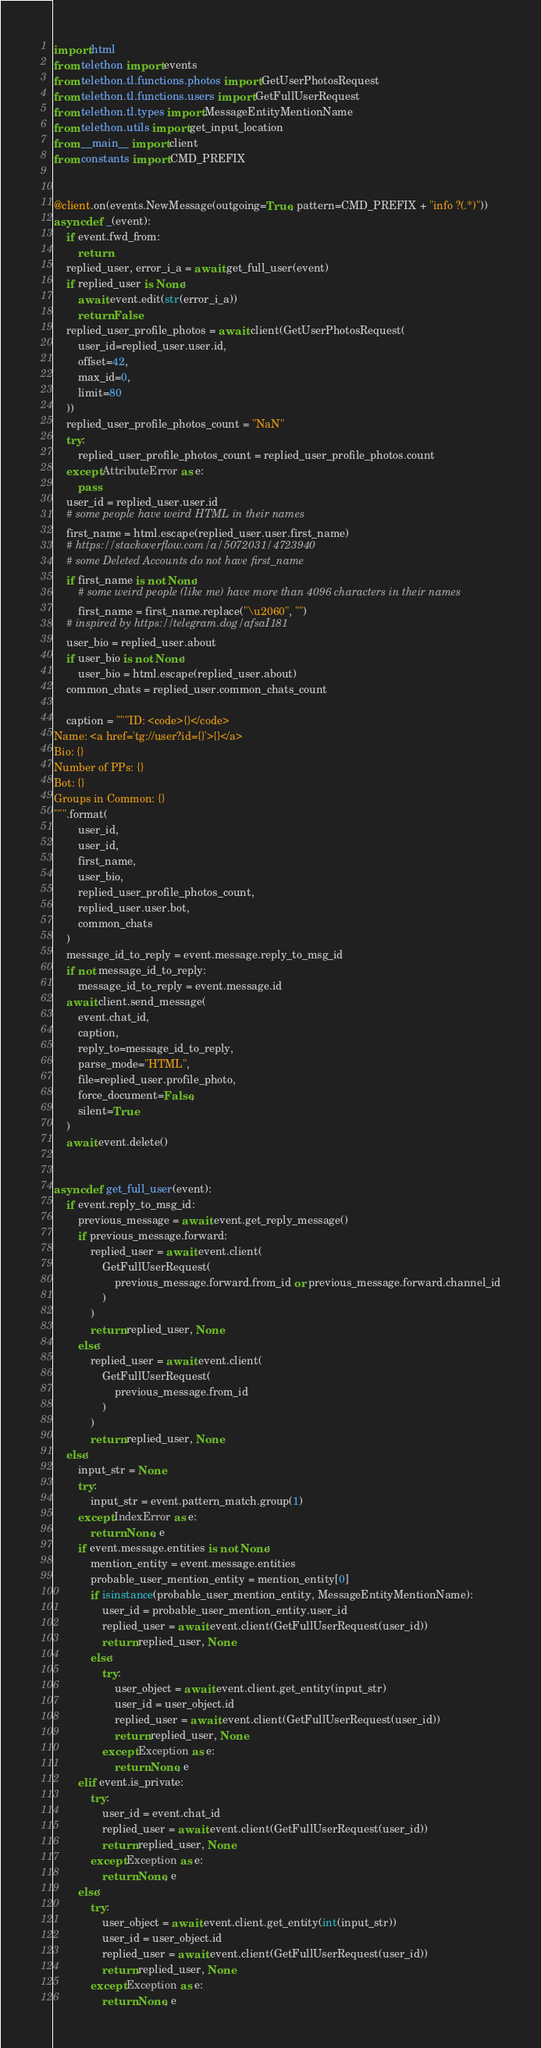Convert code to text. <code><loc_0><loc_0><loc_500><loc_500><_Python_>import html
from telethon import events
from telethon.tl.functions.photos import GetUserPhotosRequest
from telethon.tl.functions.users import GetFullUserRequest
from telethon.tl.types import MessageEntityMentionName
from telethon.utils import get_input_location
from __main__ import client
from constants import CMD_PREFIX


@client.on(events.NewMessage(outgoing=True, pattern=CMD_PREFIX + "info ?(.*)"))
async def _(event):
    if event.fwd_from:
        return
    replied_user, error_i_a = await get_full_user(event)
    if replied_user is None:
        await event.edit(str(error_i_a))
        return False
    replied_user_profile_photos = await client(GetUserPhotosRequest(
        user_id=replied_user.user.id,
        offset=42,
        max_id=0,
        limit=80
    ))
    replied_user_profile_photos_count = "NaN"
    try:
        replied_user_profile_photos_count = replied_user_profile_photos.count
    except AttributeError as e:
        pass
    user_id = replied_user.user.id
    # some people have weird HTML in their names
    first_name = html.escape(replied_user.user.first_name)
    # https://stackoverflow.com/a/5072031/4723940
    # some Deleted Accounts do not have first_name
    if first_name is not None:
        # some weird people (like me) have more than 4096 characters in their names
        first_name = first_name.replace("\u2060", "")
    # inspired by https://telegram.dog/afsaI181
    user_bio = replied_user.about
    if user_bio is not None:
        user_bio = html.escape(replied_user.about)
    common_chats = replied_user.common_chats_count
    
    caption = """ID: <code>{}</code>
Name: <a href='tg://user?id={}'>{}</a>
Bio: {}
Number of PPs: {}
Bot: {}
Groups in Common: {}
""".format(
        user_id,
        user_id,
        first_name,
        user_bio,
        replied_user_profile_photos_count,
        replied_user.user.bot,
        common_chats
    )
    message_id_to_reply = event.message.reply_to_msg_id
    if not message_id_to_reply:
        message_id_to_reply = event.message.id
    await client.send_message(
        event.chat_id,
        caption,
        reply_to=message_id_to_reply,
        parse_mode="HTML",
        file=replied_user.profile_photo,
        force_document=False,
        silent=True
    )
    await event.delete()


async def get_full_user(event):
    if event.reply_to_msg_id:
        previous_message = await event.get_reply_message()
        if previous_message.forward:
            replied_user = await event.client(
                GetFullUserRequest(
                    previous_message.forward.from_id or previous_message.forward.channel_id
                )
            )
            return replied_user, None
        else:
            replied_user = await event.client(
                GetFullUserRequest(
                    previous_message.from_id
                )
            )
            return replied_user, None
    else:
        input_str = None
        try:
            input_str = event.pattern_match.group(1)
        except IndexError as e:
            return None, e
        if event.message.entities is not None:
            mention_entity = event.message.entities
            probable_user_mention_entity = mention_entity[0]
            if isinstance(probable_user_mention_entity, MessageEntityMentionName):
                user_id = probable_user_mention_entity.user_id
                replied_user = await event.client(GetFullUserRequest(user_id))
                return replied_user, None
            else:
                try:
                    user_object = await event.client.get_entity(input_str)
                    user_id = user_object.id
                    replied_user = await event.client(GetFullUserRequest(user_id))
                    return replied_user, None
                except Exception as e:
                    return None, e
        elif event.is_private:
            try:
                user_id = event.chat_id
                replied_user = await event.client(GetFullUserRequest(user_id))
                return replied_user, None
            except Exception as e:
                return None, e
        else:
            try:
                user_object = await event.client.get_entity(int(input_str))
                user_id = user_object.id
                replied_user = await event.client(GetFullUserRequest(user_id))
                return replied_user, None
            except Exception as e:
                return None, e</code> 